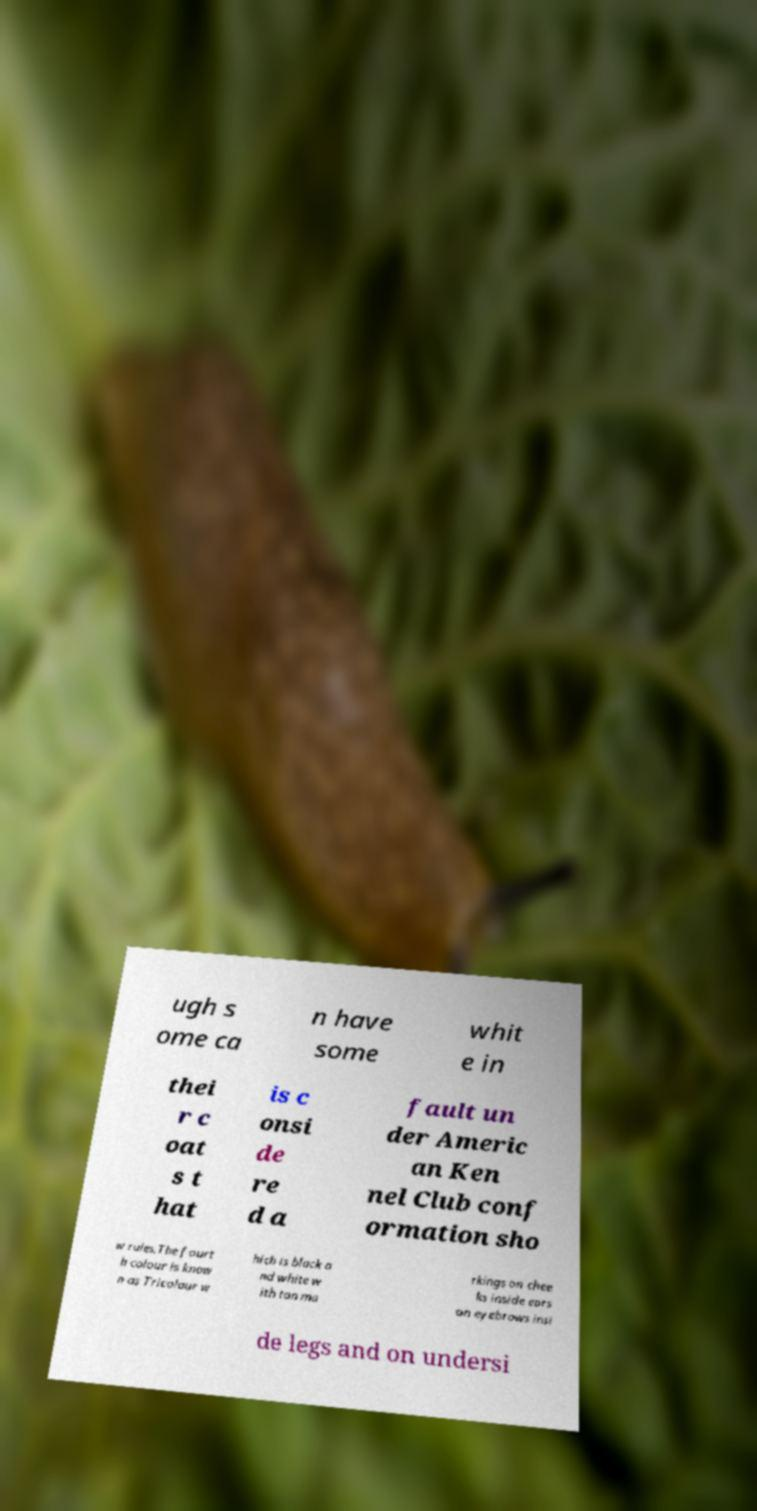There's text embedded in this image that I need extracted. Can you transcribe it verbatim? ugh s ome ca n have some whit e in thei r c oat s t hat is c onsi de re d a fault un der Americ an Ken nel Club conf ormation sho w rules.The fourt h colour is know n as Tricolour w hich is black a nd white w ith tan ma rkings on chee ks inside ears on eyebrows insi de legs and on undersi 